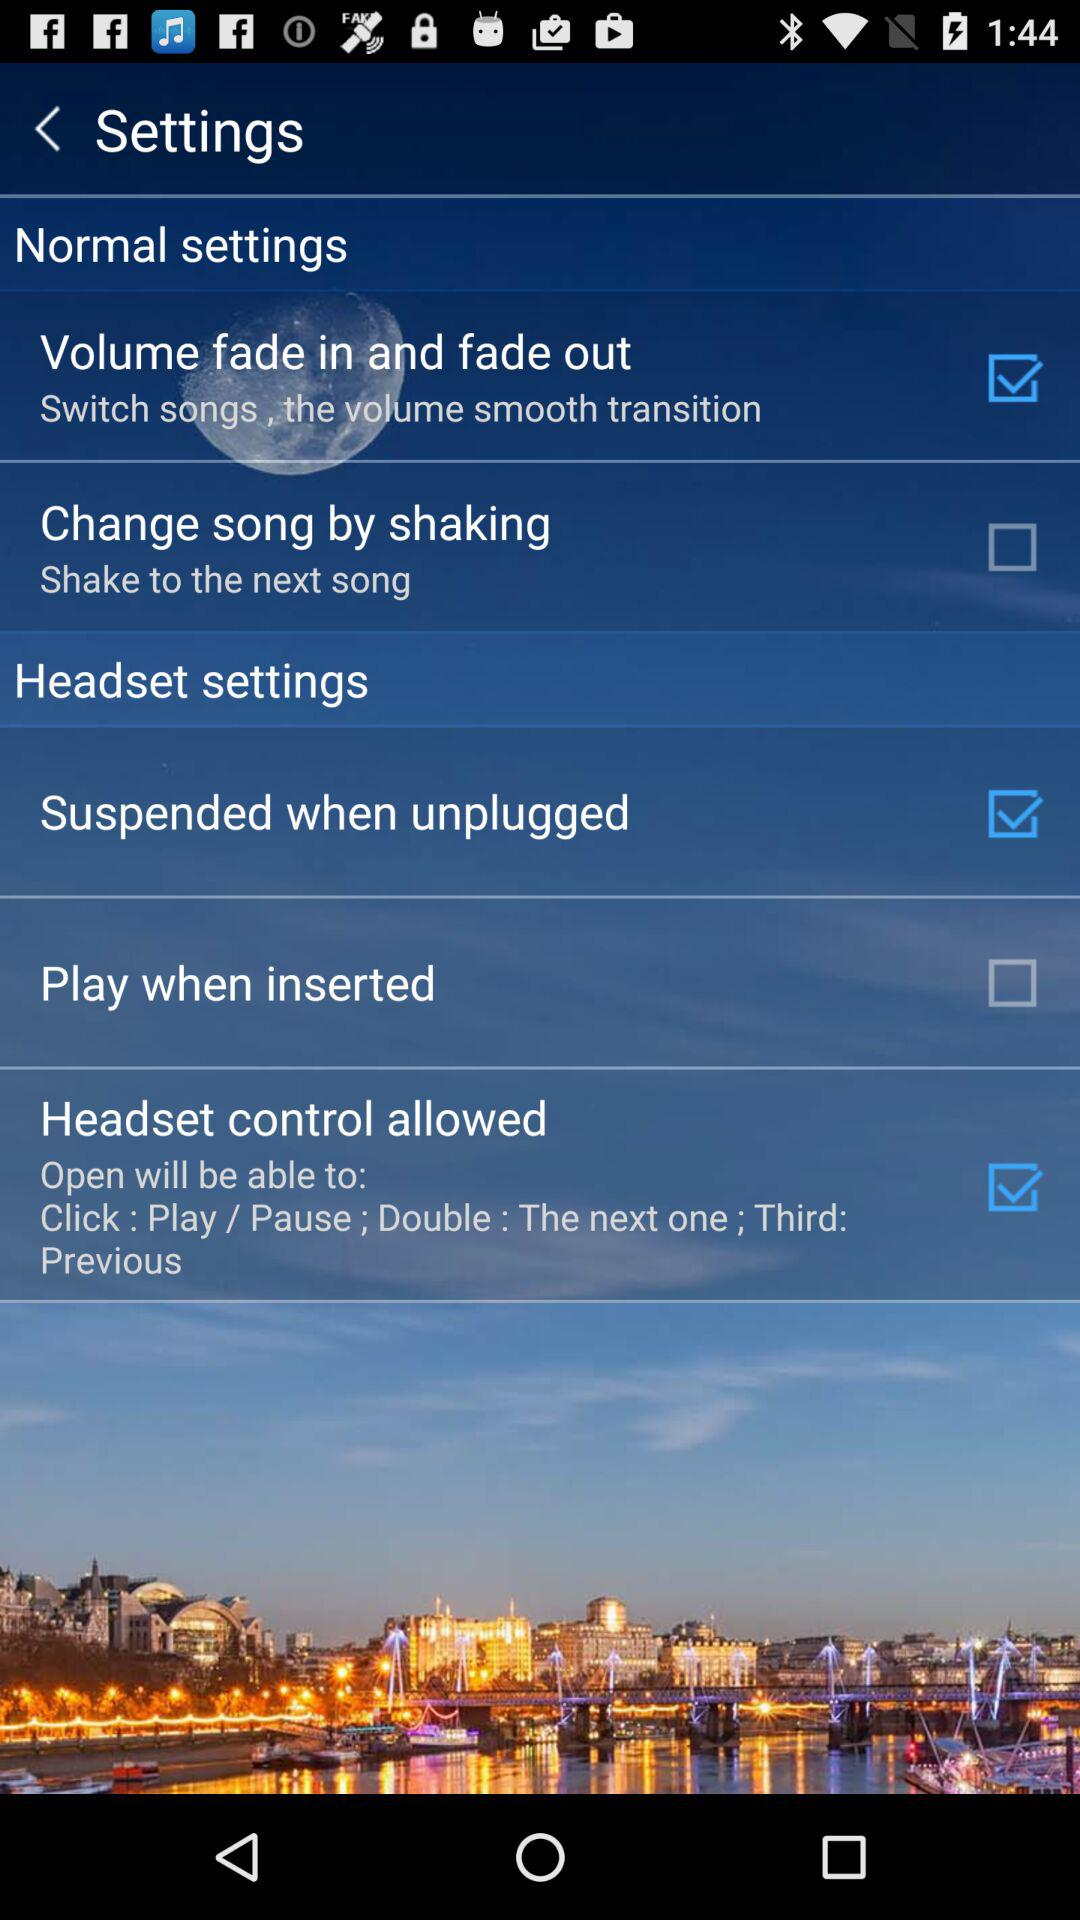What is the status of "Play when inserted"? The status of "Play when inserted" is "off". 